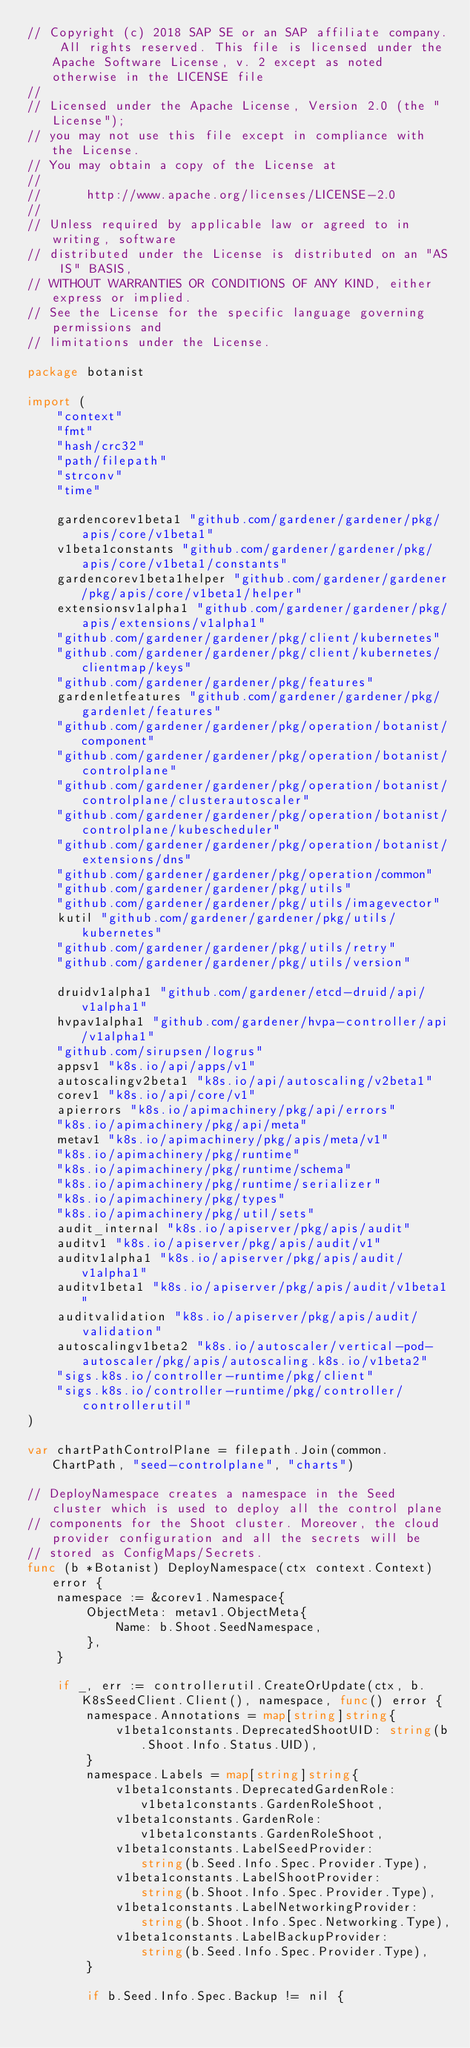<code> <loc_0><loc_0><loc_500><loc_500><_Go_>// Copyright (c) 2018 SAP SE or an SAP affiliate company. All rights reserved. This file is licensed under the Apache Software License, v. 2 except as noted otherwise in the LICENSE file
//
// Licensed under the Apache License, Version 2.0 (the "License");
// you may not use this file except in compliance with the License.
// You may obtain a copy of the License at
//
//      http://www.apache.org/licenses/LICENSE-2.0
//
// Unless required by applicable law or agreed to in writing, software
// distributed under the License is distributed on an "AS IS" BASIS,
// WITHOUT WARRANTIES OR CONDITIONS OF ANY KIND, either express or implied.
// See the License for the specific language governing permissions and
// limitations under the License.

package botanist

import (
	"context"
	"fmt"
	"hash/crc32"
	"path/filepath"
	"strconv"
	"time"

	gardencorev1beta1 "github.com/gardener/gardener/pkg/apis/core/v1beta1"
	v1beta1constants "github.com/gardener/gardener/pkg/apis/core/v1beta1/constants"
	gardencorev1beta1helper "github.com/gardener/gardener/pkg/apis/core/v1beta1/helper"
	extensionsv1alpha1 "github.com/gardener/gardener/pkg/apis/extensions/v1alpha1"
	"github.com/gardener/gardener/pkg/client/kubernetes"
	"github.com/gardener/gardener/pkg/client/kubernetes/clientmap/keys"
	"github.com/gardener/gardener/pkg/features"
	gardenletfeatures "github.com/gardener/gardener/pkg/gardenlet/features"
	"github.com/gardener/gardener/pkg/operation/botanist/component"
	"github.com/gardener/gardener/pkg/operation/botanist/controlplane"
	"github.com/gardener/gardener/pkg/operation/botanist/controlplane/clusterautoscaler"
	"github.com/gardener/gardener/pkg/operation/botanist/controlplane/kubescheduler"
	"github.com/gardener/gardener/pkg/operation/botanist/extensions/dns"
	"github.com/gardener/gardener/pkg/operation/common"
	"github.com/gardener/gardener/pkg/utils"
	"github.com/gardener/gardener/pkg/utils/imagevector"
	kutil "github.com/gardener/gardener/pkg/utils/kubernetes"
	"github.com/gardener/gardener/pkg/utils/retry"
	"github.com/gardener/gardener/pkg/utils/version"

	druidv1alpha1 "github.com/gardener/etcd-druid/api/v1alpha1"
	hvpav1alpha1 "github.com/gardener/hvpa-controller/api/v1alpha1"
	"github.com/sirupsen/logrus"
	appsv1 "k8s.io/api/apps/v1"
	autoscalingv2beta1 "k8s.io/api/autoscaling/v2beta1"
	corev1 "k8s.io/api/core/v1"
	apierrors "k8s.io/apimachinery/pkg/api/errors"
	"k8s.io/apimachinery/pkg/api/meta"
	metav1 "k8s.io/apimachinery/pkg/apis/meta/v1"
	"k8s.io/apimachinery/pkg/runtime"
	"k8s.io/apimachinery/pkg/runtime/schema"
	"k8s.io/apimachinery/pkg/runtime/serializer"
	"k8s.io/apimachinery/pkg/types"
	"k8s.io/apimachinery/pkg/util/sets"
	audit_internal "k8s.io/apiserver/pkg/apis/audit"
	auditv1 "k8s.io/apiserver/pkg/apis/audit/v1"
	auditv1alpha1 "k8s.io/apiserver/pkg/apis/audit/v1alpha1"
	auditv1beta1 "k8s.io/apiserver/pkg/apis/audit/v1beta1"
	auditvalidation "k8s.io/apiserver/pkg/apis/audit/validation"
	autoscalingv1beta2 "k8s.io/autoscaler/vertical-pod-autoscaler/pkg/apis/autoscaling.k8s.io/v1beta2"
	"sigs.k8s.io/controller-runtime/pkg/client"
	"sigs.k8s.io/controller-runtime/pkg/controller/controllerutil"
)

var chartPathControlPlane = filepath.Join(common.ChartPath, "seed-controlplane", "charts")

// DeployNamespace creates a namespace in the Seed cluster which is used to deploy all the control plane
// components for the Shoot cluster. Moreover, the cloud provider configuration and all the secrets will be
// stored as ConfigMaps/Secrets.
func (b *Botanist) DeployNamespace(ctx context.Context) error {
	namespace := &corev1.Namespace{
		ObjectMeta: metav1.ObjectMeta{
			Name: b.Shoot.SeedNamespace,
		},
	}

	if _, err := controllerutil.CreateOrUpdate(ctx, b.K8sSeedClient.Client(), namespace, func() error {
		namespace.Annotations = map[string]string{
			v1beta1constants.DeprecatedShootUID: string(b.Shoot.Info.Status.UID),
		}
		namespace.Labels = map[string]string{
			v1beta1constants.DeprecatedGardenRole:    v1beta1constants.GardenRoleShoot,
			v1beta1constants.GardenRole:              v1beta1constants.GardenRoleShoot,
			v1beta1constants.LabelSeedProvider:       string(b.Seed.Info.Spec.Provider.Type),
			v1beta1constants.LabelShootProvider:      string(b.Shoot.Info.Spec.Provider.Type),
			v1beta1constants.LabelNetworkingProvider: string(b.Shoot.Info.Spec.Networking.Type),
			v1beta1constants.LabelBackupProvider:     string(b.Seed.Info.Spec.Provider.Type),
		}

		if b.Seed.Info.Spec.Backup != nil {</code> 